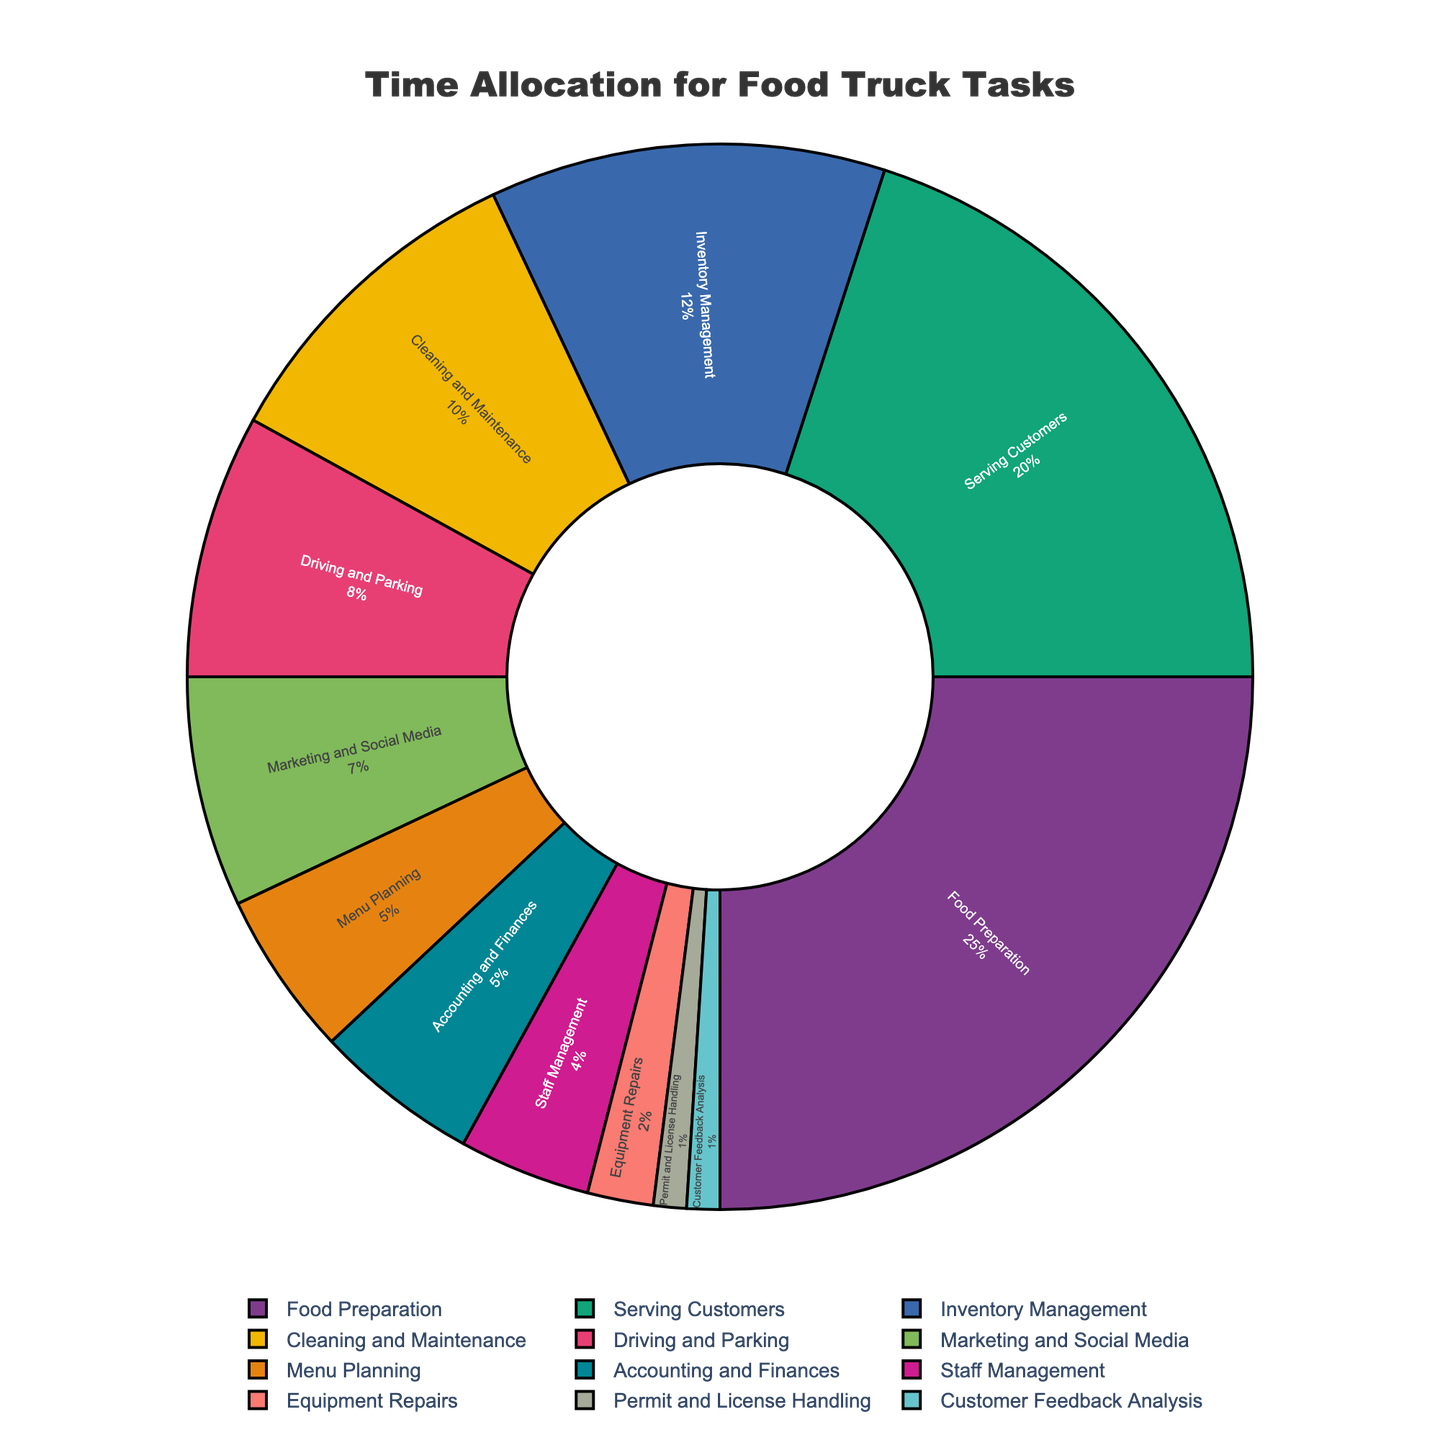What task takes up the largest portion of time? To determine the task that takes up the largest portion of time, look at the task with the highest percentage on the pie chart. "Food Preparation" has the largest slice.
Answer: Food Preparation Which two tasks combined take up the same percentage as Food Preparation? "Food Preparation" takes 25%. Look for two tasks whose percentages add up to 25%. "Serving Customers" (20%) and "Permits and License Handling" (1%) combined add up to 25%.
Answer: Serving Customers and Permit and License Handling What is the difference in time allocation between "Inventory Management" and "Staff Management"? "Inventory Management" has 12%, and "Staff Management" has 4%. Subtract Staff Management's percentage from Inventory Management's. 12% - 4% = 8%.
Answer: 8% If you summed up the time allocated to "Cleaning and Maintenance", "Driving and Parking", and "Marketing and Social Media", would it be more or less than "Food Preparation"? Add the percentages of the three tasks: Cleaning and Maintenance (10%) + Driving and Parking (8%) + Marketing and Social Media (7%) = 25%, which equals Food Preparation.
Answer: Equal to Which task has the smallest allocation of time? Look at the task with the smallest percentage on the pie chart. "Customer Feedback Analysis" and "Permit and License Handling" both have the smallest slice at 1%.
Answer: Customer Feedback Analysis and Permit and License Handling How much more time is allocated to "Serving Customers" than "Menu Planning"? Serving Customers takes 20%, and Menu Planning takes 5%. Subtract Menu Planning's percentage from Serving Customers': 20% - 5% = 15%.
Answer: 15% What fraction of the time is spent on "Driving and Parking" compared to "Cleaning and Maintenance"? "Driving and Parking" is 8%, and "Cleaning and Maintenance" is 10%. The fraction is 8%/10% = 4/5 or 0.8.
Answer: 0.8 If you had to combine "Accounting and Finances" with one other task to make up the "Serving Customers" percentage, which task would you choose? "Serving Customers" is 20%. "Accounting and Finances" is 5%, so you need 15% more. No single task has exactly 15%, but "Menu Planning" (5%) and "Staff Management" (4%) together with another 6% could get close to a combination. However, the most straightforward addition would be "Food Preparation" (25%) which is slightly above.
Answer: No perfect match, but near combinations can be made like adding Food Preparation Which task pair's combined time equals "Inventory Management"? "Inventory Management" is 12%. Look for two tasks that add up to 12%. "Cleaning and Maintenance" (10%) and "Permit and License Handling" (1%) + "Customer Feedback Analysis" (1%) together add up to 12%.
Answer: Cleaning and Maintenance and Permit and License Handling + Customer Feedback Analysis Which color is used to represent "Marketing and Social Media"? Identify the color directly used for "Marketing and Social Media" from the chart. As the specific color is unknown without seeing the chart, we can't provide an accurate answer.
Answer: Unable to determine 